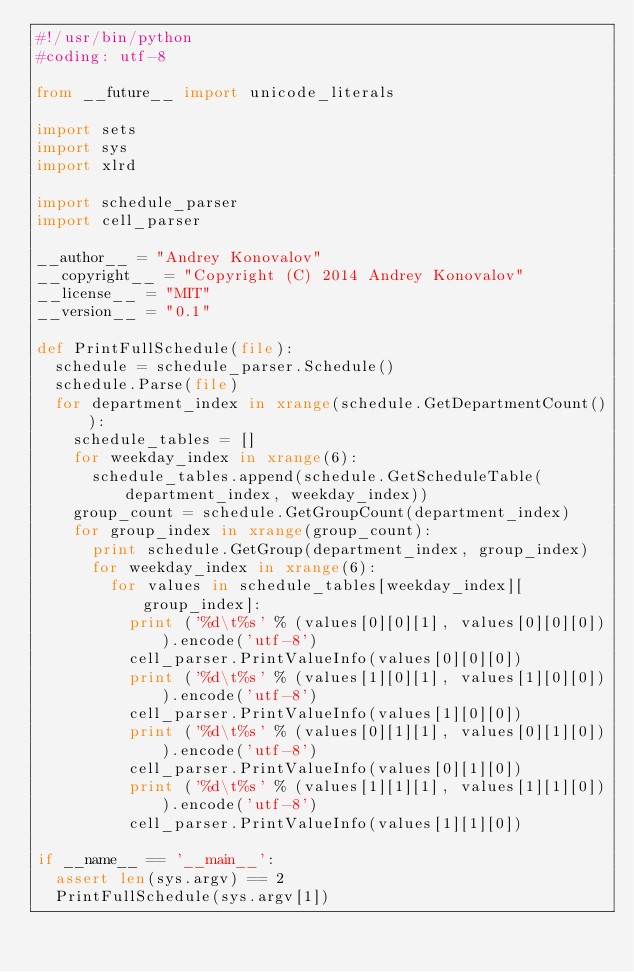<code> <loc_0><loc_0><loc_500><loc_500><_Python_>#!/usr/bin/python
#coding: utf-8

from __future__ import unicode_literals

import sets
import sys
import xlrd

import schedule_parser
import cell_parser

__author__ = "Andrey Konovalov"
__copyright__ = "Copyright (C) 2014 Andrey Konovalov"
__license__ = "MIT"
__version__ = "0.1"

def PrintFullSchedule(file):
  schedule = schedule_parser.Schedule()
  schedule.Parse(file)
  for department_index in xrange(schedule.GetDepartmentCount()):
    schedule_tables = []
    for weekday_index in xrange(6):
      schedule_tables.append(schedule.GetScheduleTable(department_index, weekday_index))
    group_count = schedule.GetGroupCount(department_index)
    for group_index in xrange(group_count):
      print schedule.GetGroup(department_index, group_index)
      for weekday_index in xrange(6):
        for values in schedule_tables[weekday_index][group_index]:
          print ('%d\t%s' % (values[0][0][1], values[0][0][0])).encode('utf-8')
          cell_parser.PrintValueInfo(values[0][0][0])
          print ('%d\t%s' % (values[1][0][1], values[1][0][0])).encode('utf-8')
          cell_parser.PrintValueInfo(values[1][0][0])
          print ('%d\t%s' % (values[0][1][1], values[0][1][0])).encode('utf-8')
          cell_parser.PrintValueInfo(values[0][1][0])
          print ('%d\t%s' % (values[1][1][1], values[1][1][0])).encode('utf-8')
          cell_parser.PrintValueInfo(values[1][1][0])

if __name__ == '__main__':
  assert len(sys.argv) == 2
  PrintFullSchedule(sys.argv[1])
</code> 